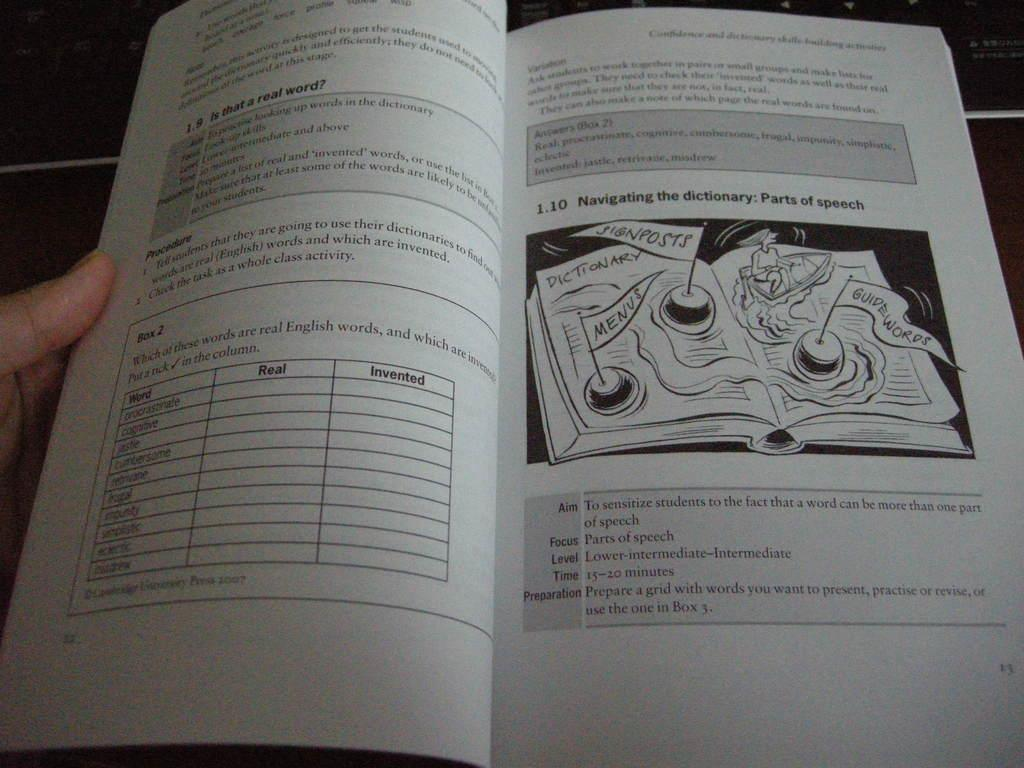<image>
Write a terse but informative summary of the picture. a book with a picture on the page of a dictionary 